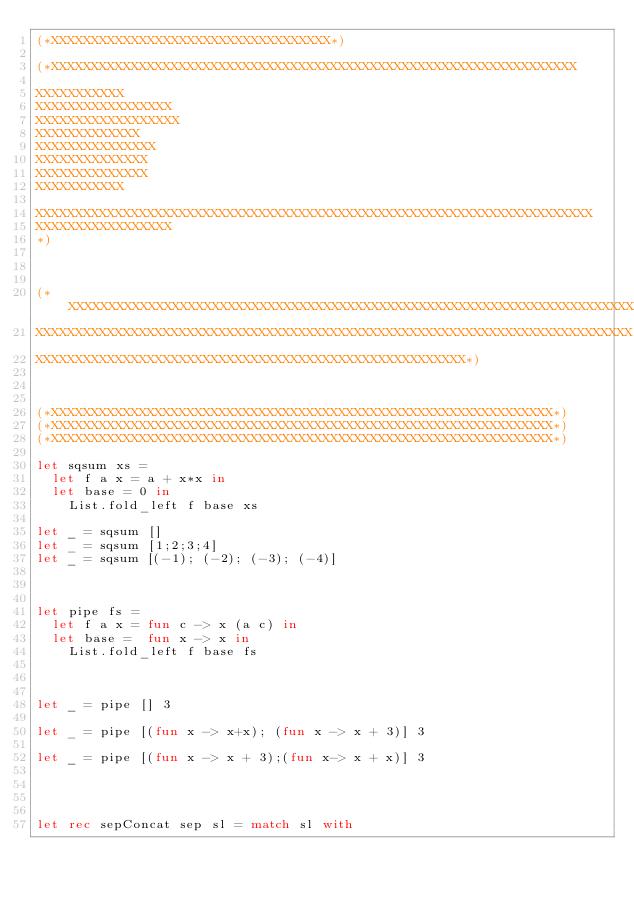<code> <loc_0><loc_0><loc_500><loc_500><_OCaml_>(*XXXXXXXXXXXXXXXXXXXXXXXXXXXXXXXXXXX*)

(*XXXXXXXXXXXXXXXXXXXXXXXXXXXXXXXXXXXXXXXXXXXXXXXXXXXXXXXXXXXXXXXXXX

XXXXXXXXXXX
XXXXXXXXXXXXXXXXX
XXXXXXXXXXXXXXXXXX
XXXXXXXXXXXXX
XXXXXXXXXXXXXXX
XXXXXXXXXXXXXX
XXXXXXXXXXXXXX
XXXXXXXXXXX

XXXXXXXXXXXXXXXXXXXXXXXXXXXXXXXXXXXXXXXXXXXXXXXXXXXXXXXXXXXXXXXXXXXXXX
XXXXXXXXXXXXXXXXX
*)



(*XXXXXXXXXXXXXXXXXXXXXXXXXXXXXXXXXXXXXXXXXXXXXXXXXXXXXXXXXXXXXXXXXXXXXXXXXXX
XXXXXXXXXXXXXXXXXXXXXXXXXXXXXXXXXXXXXXXXXXXXXXXXXXXXXXXXXXXXXXXXXXXXXXXXXXX
XXXXXXXXXXXXXXXXXXXXXXXXXXXXXXXXXXXXXXXXXXXXXXXXXXXXXX*)



(*XXXXXXXXXXXXXXXXXXXXXXXXXXXXXXXXXXXXXXXXXXXXXXXXXXXXXXXXXXXXXXX*)
(*XXXXXXXXXXXXXXXXXXXXXXXXXXXXXXXXXXXXXXXXXXXXXXXXXXXXXXXXXXXXXXX*)
(*XXXXXXXXXXXXXXXXXXXXXXXXXXXXXXXXXXXXXXXXXXXXXXXXXXXXXXXXXXXXXXX*)

let sqsum xs = 
  let f a x = a + x*x in
  let base = 0 in
    List.fold_left f base xs

let _ = sqsum []
let _ = sqsum [1;2;3;4]
let _ = sqsum [(-1); (-2); (-3); (-4)]



let pipe fs = 
  let f a x = fun c -> x (a c) in
  let base =  fun x -> x in
    List.fold_left f base fs



let _ = pipe [] 3

let _ = pipe [(fun x -> x+x); (fun x -> x + 3)] 3

let _ = pipe [(fun x -> x + 3);(fun x-> x + x)] 3




let rec sepConcat sep sl = match sl with </code> 